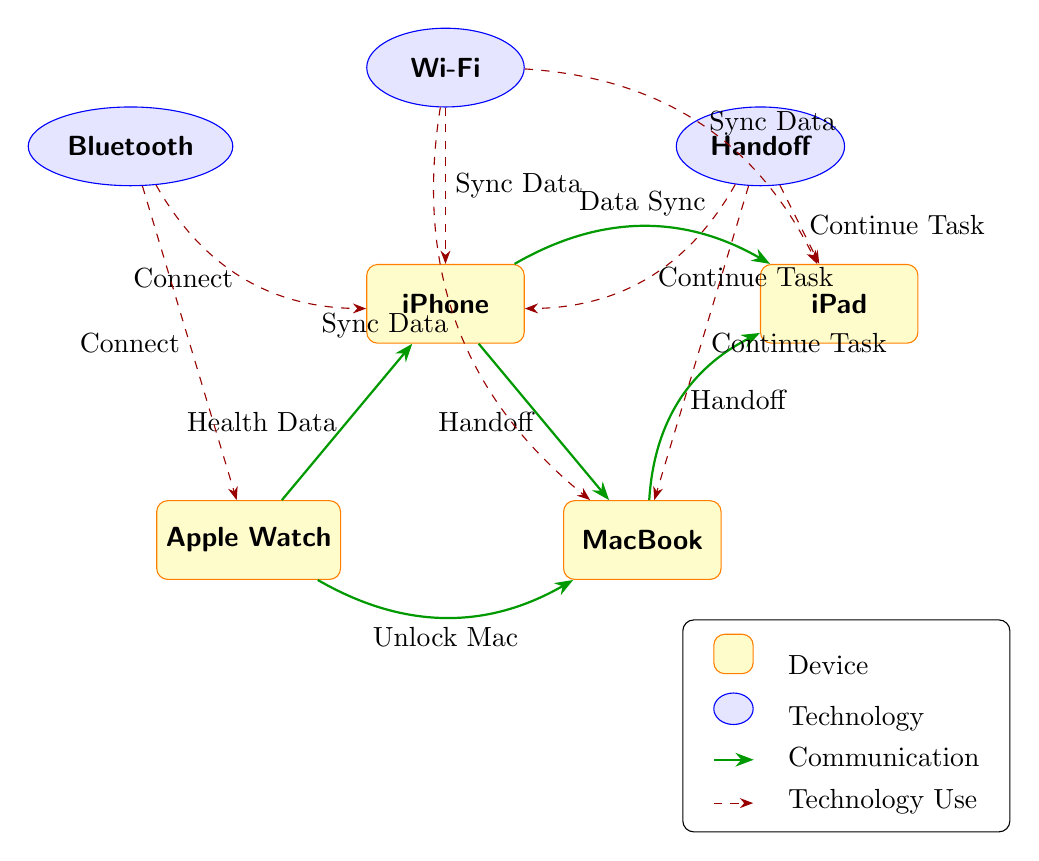What devices are connected to Bluetooth? The diagram shows that both iPhone and Apple Watch are using Bluetooth technology to connect. By checking the edges labeled "Connect," we see both devices directly linked to the Bluetooth node.
Answer: iPhone, Apple Watch How many technologies are used in the diagram? There are three technologies represented in the diagram: Bluetooth, Wi-Fi, and Handoff. This can be counted by identifying the technology nodes in the upper section of the diagram.
Answer: 3 What type of data does Apple Watch share with iPhone? The Apple Watch shares "Health Data" with the iPhone, as indicated by the direct communication edge labeled "Health Data" between the two device nodes.
Answer: Health Data Which device can be unlocked using the Apple Watch? According to the diagram, the Apple Watch can unlock the MacBook, represented by the communication line with the label "Unlock Mac" connecting the Apple Watch and MacBook nodes.
Answer: MacBook How does the iPhone communicate with the iPad? The iPhone communicates with the iPad through "Data Sync," shown by the communication edge labeled with that term connecting the two device nodes.
Answer: Data Sync What is the main function of the Handoff technology? Handoff is illustrated in the diagram as allowing devices to "Continue Task," indicated by the edges connecting the iPhone, MacBook, and iPad, all labeled accordingly.
Answer: Continue Task How many communication edges involve the MacBook? The MacBook is involved in three communication edges: one with the iPhone (Handoff), one with the iPad (Handoff), and one with the Apple Watch (Unlock Mac). This is determined by counting the edges connected to the MacBook node.
Answer: 3 Which technology is used for syncing data between iPad and iPhone? The technology used for syncing data between the iPad and iPhone is Wi-Fi, as indicated by the edge labeled "Sync Data" that connects both devices to the Wi-Fi technology node.
Answer: Wi-Fi What are the communication flows related to the iPhone? The iPhone has two communication flows: to the iPad labeled "Data Sync" and to the MacBook labeled "Handoff." This is gathered by tracing edges leading from the iPhone node to its connected devices.
Answer: Data Sync, Handoff 